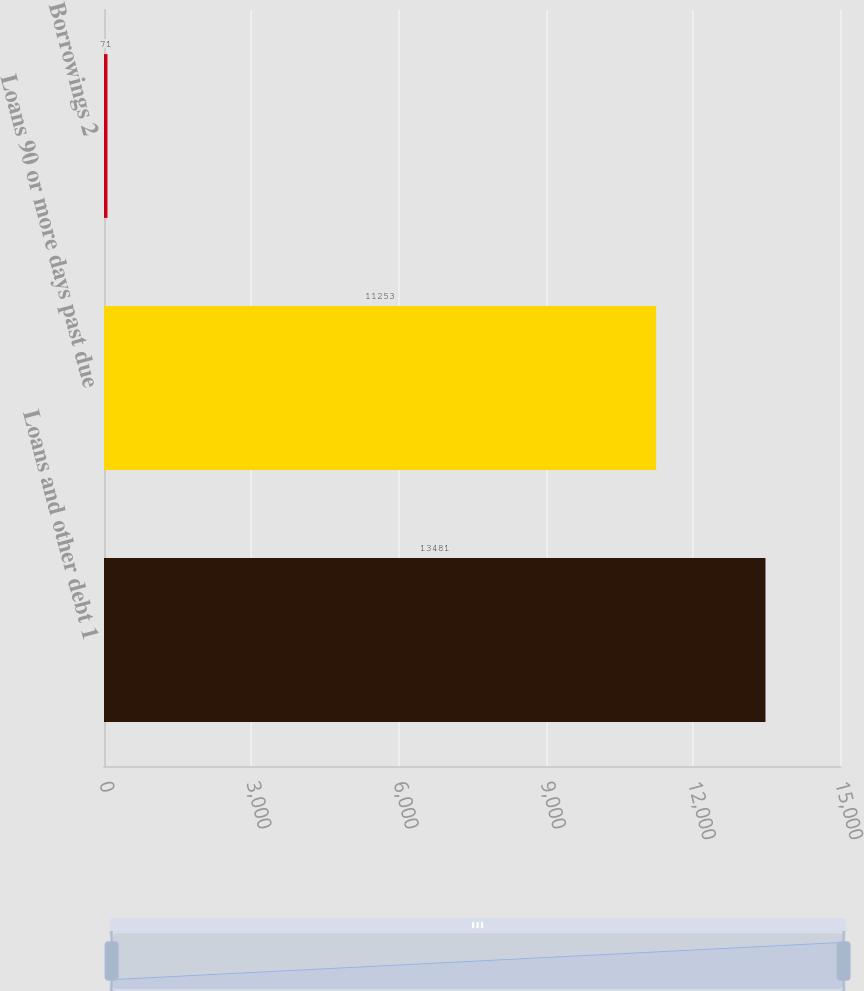<chart> <loc_0><loc_0><loc_500><loc_500><bar_chart><fcel>Loans and other debt 1<fcel>Loans 90 or more days past due<fcel>Borrowings 2<nl><fcel>13481<fcel>11253<fcel>71<nl></chart> 